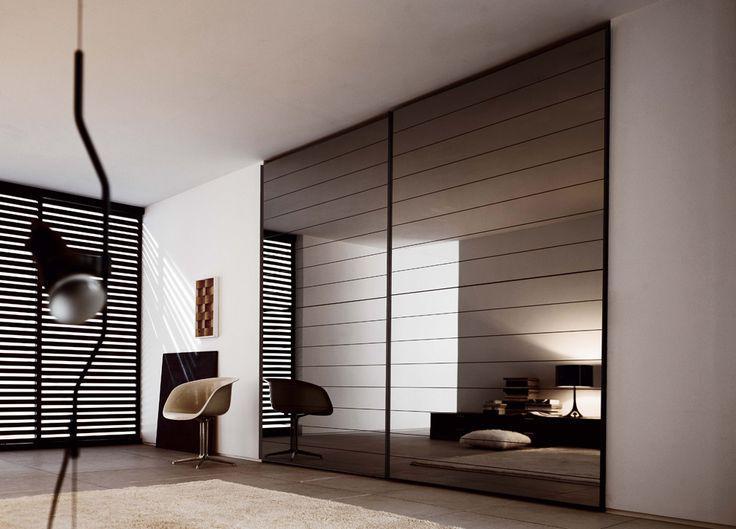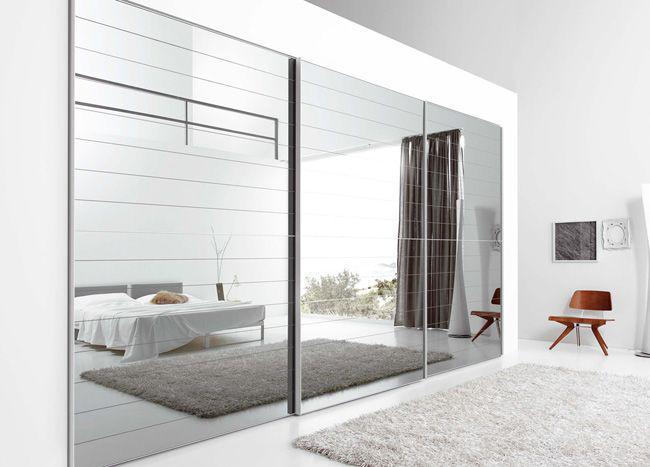The first image is the image on the left, the second image is the image on the right. Analyze the images presented: Is the assertion "An image shows a closed sliding-door unit with at least one mirrored center panel flanked by brown wood panels on the sides." valid? Answer yes or no. No. The first image is the image on the left, the second image is the image on the right. Assess this claim about the two images: "A plant is near a sliding cabinet in one of the images.". Correct or not? Answer yes or no. No. 